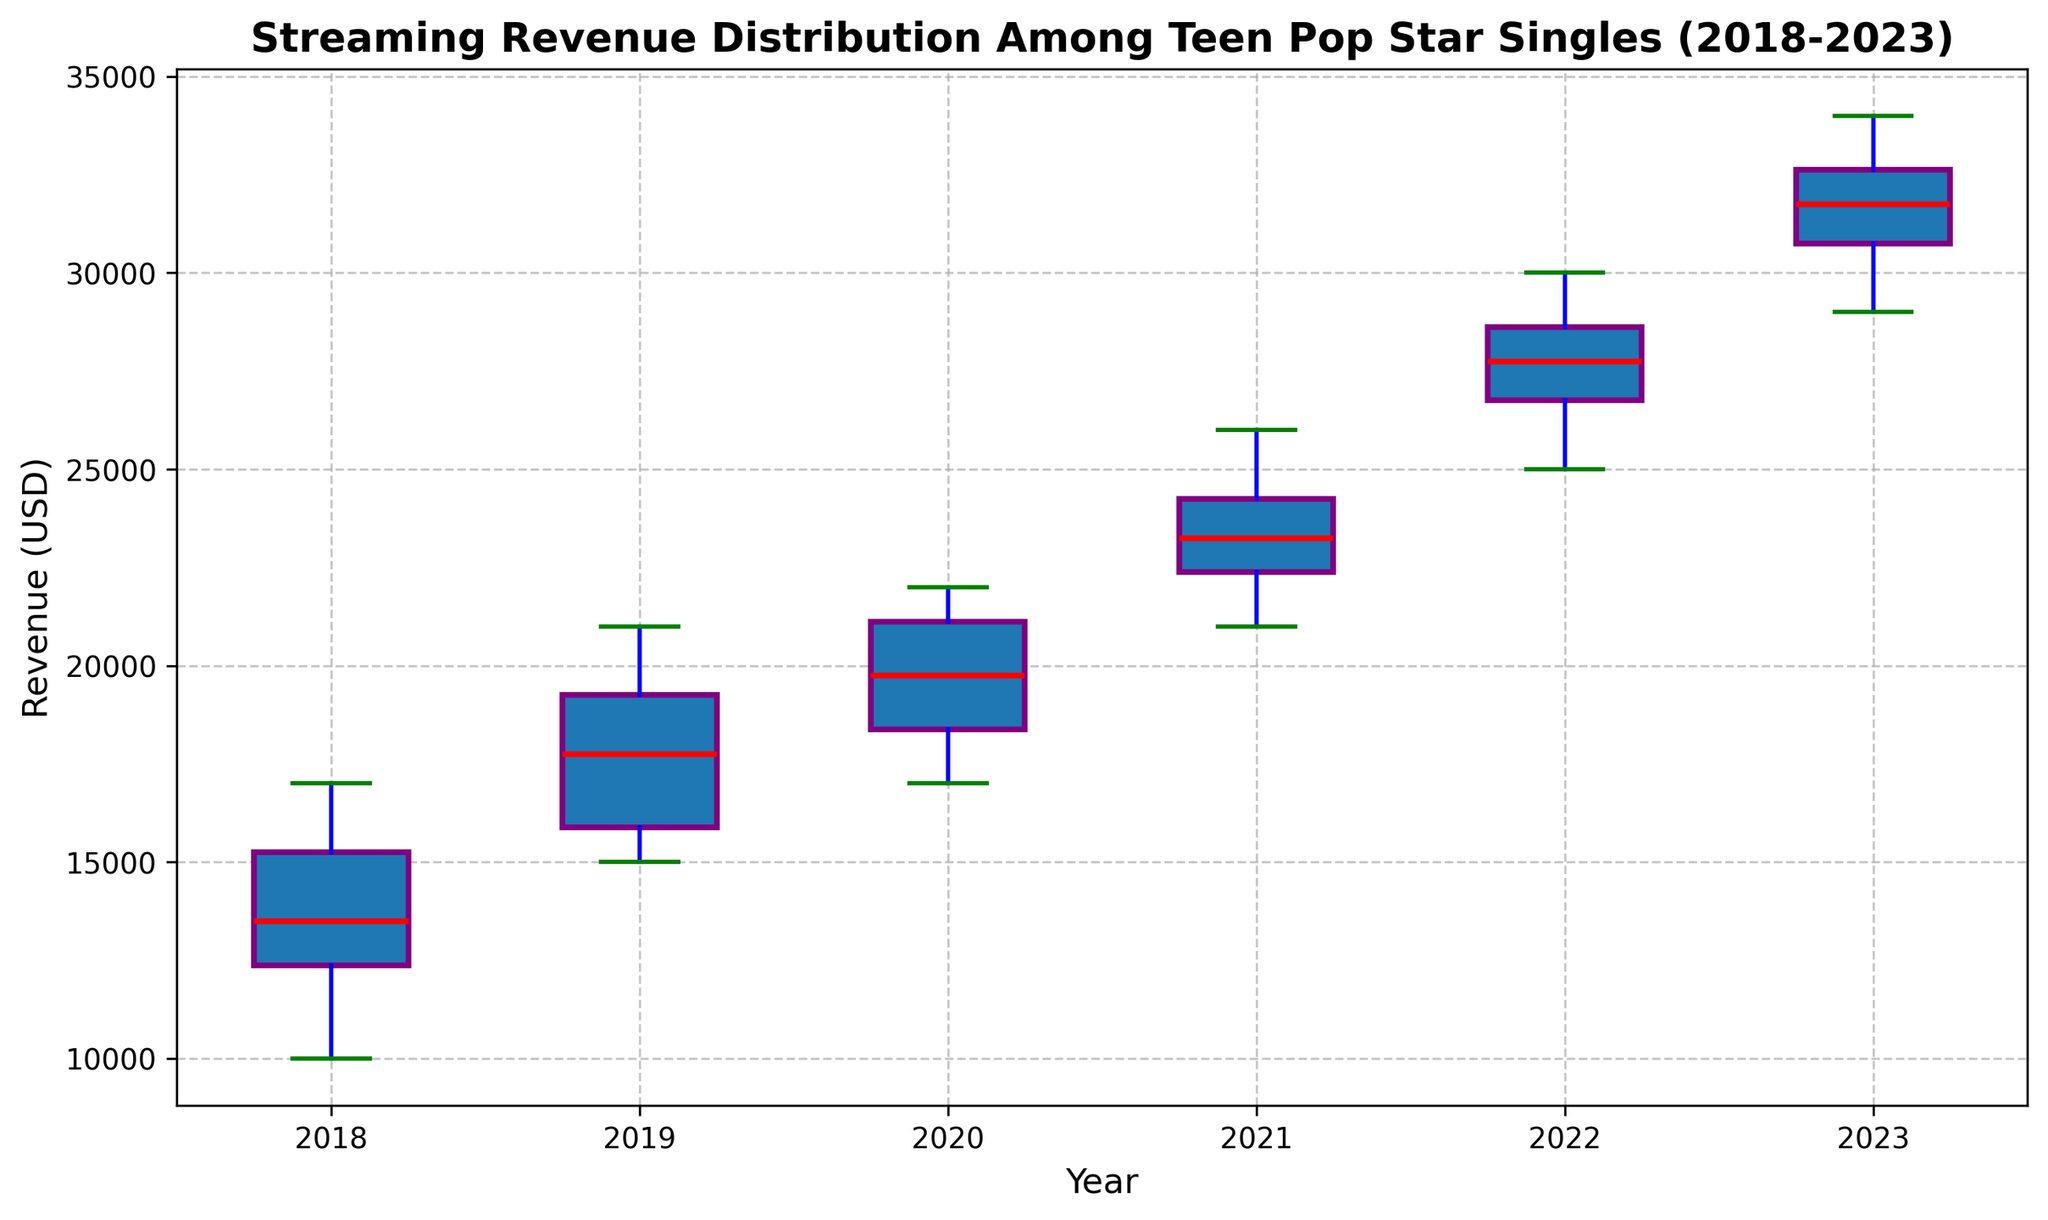What's the median revenue for the year 2023? To find the median revenue for 2023, look for the middle value in the box of the box plot for 2023. The median is represented by the red line in the middle of the box.
Answer: 31750 Which year had the highest median revenue? To determine the year with the highest median revenue, compare the median lines (red) of the boxes across all years. The year with the highest median line is the answer.
Answer: 2023 In which year was the revenue spread the widest? To find the year with the widest revenue spread, look for the year with the tallest box and whiskers combined. The tallest box with whiskers indicates the widest spread.
Answer: 2022 How did the revenue distribution change from 2018 to 2023? To understand the change, observe the boxes from 2018 to 2023. Note the position of the boxes, the distance between the top and bottom whiskers, and the movement of the median lines. The boxes and whiskers moved higher, and the boxes generally became taller, indicating an upward shift and wider distribution over the years.
Answer: Revenue increased, and distribution widened What is the interquartile range (IQR) for the year 2020? The IQR is the difference between the third quartile (top of the box) and the first quartile (bottom of the box). Find the top and bottom of the box for 2020 and subtract the lower value from the higher one.
Answer: 4000 Which year had the smallest range of revenue? The smallest range corresponds to the year with the shortest whiskers combined with the box. Look for the year with the most compact representation from whisker end to whisker end.
Answer: 2018 What is the trend of median revenue over the years from 2018 to 2023? To identify the trend, examine the movement of the median lines (red) across the boxes from 2018 to 2023. The median lines show a rising trend over the years.
Answer: Increasing Which year had the most outliers? Outliers in a box plot are indicated by individual points outside the whiskers. Count these points for each year to determine which year has the most.
Answer: 2020 How does the revenue distribution in 2022 compare to that in 2019? Compare the sizes and positions of the boxes and whiskers for 2022 and 2019. Note the differences in the range of revenues, medians, and the spread of distributions. 2022 has a higher median and wider distribution than 2019.
Answer: Higher median and wider distribution in 2022 